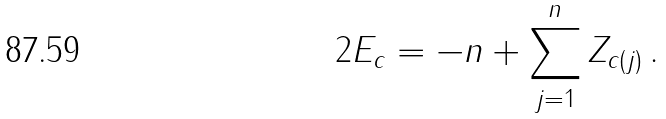<formula> <loc_0><loc_0><loc_500><loc_500>2 E _ { c } = - n + \sum _ { j = 1 } ^ { n } Z _ { c ( j ) } \, .</formula> 